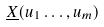Convert formula to latex. <formula><loc_0><loc_0><loc_500><loc_500>\underline { X } ( u _ { 1 } \dots , u _ { m } )</formula> 